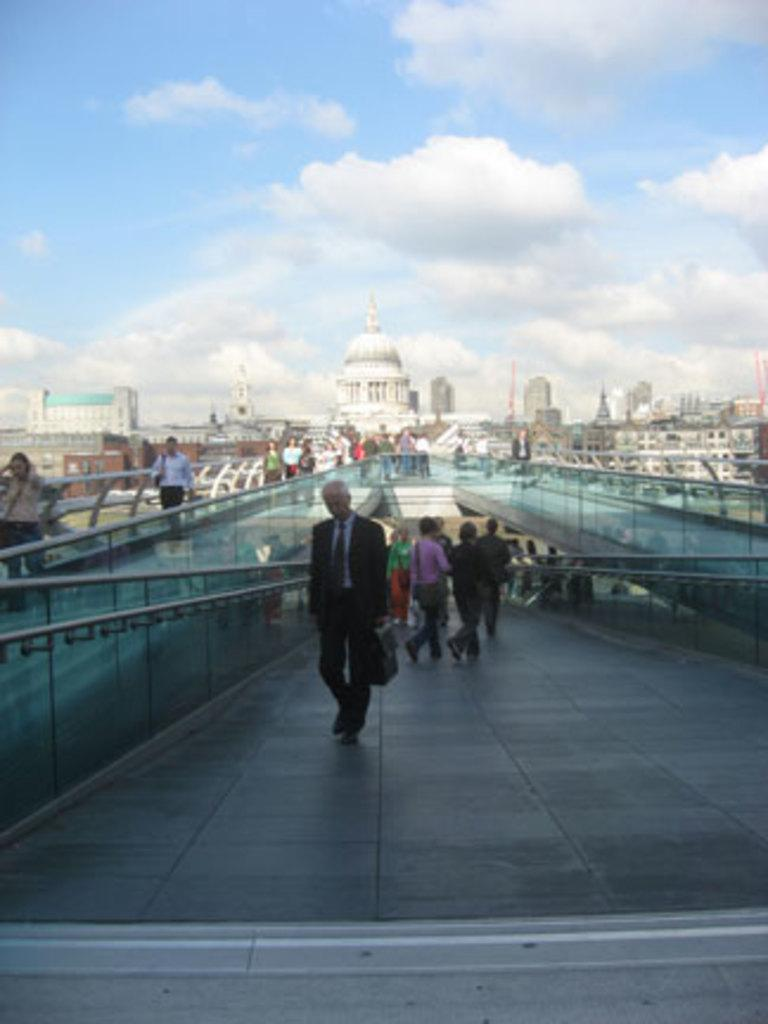What can be seen in the foreground of the picture? There are people and bridges in the foreground of the picture. What type of structures are visible in the background of the picture? There are buildings in the background of the picture. How would you describe the weather in the image? The sky is sunny, which suggests good weather. Where is the pig located in the image? There is no pig present in the image. What is the plot of the story being told in the image? The image does not depict a story or plot; it is a photograph of people, bridges, buildings, and a sunny sky. 